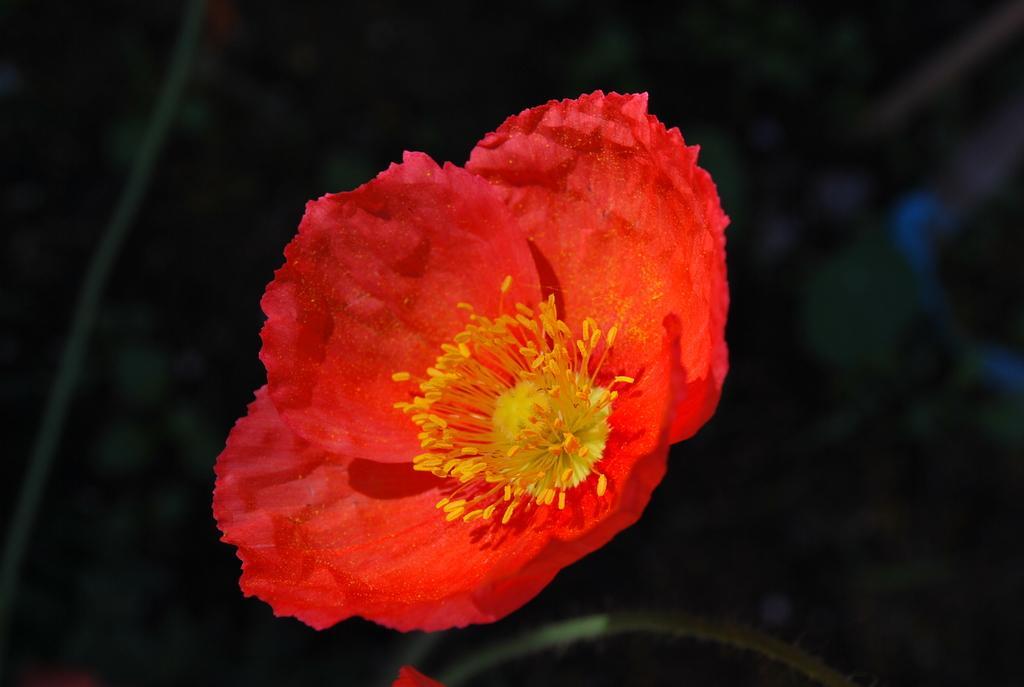How would you summarize this image in a sentence or two? Here I can see a flower. Its petals are in red color and stamens are in yellow color. The background is in black color. 